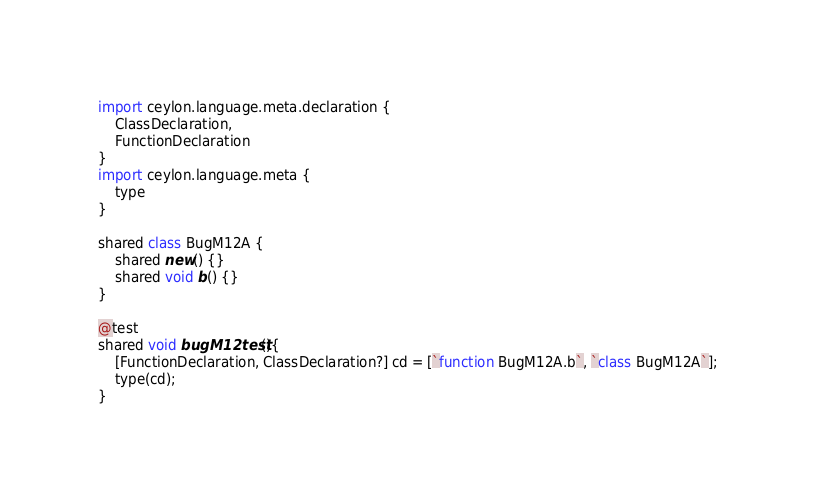Convert code to text. <code><loc_0><loc_0><loc_500><loc_500><_Ceylon_>import ceylon.language.meta.declaration {
    ClassDeclaration,
    FunctionDeclaration
}
import ceylon.language.meta {
    type
}

shared class BugM12A {
    shared new() {}    
    shared void b() {}
}

@test
shared void bugM12test(){
    [FunctionDeclaration, ClassDeclaration?] cd = [`function BugM12A.b`, `class BugM12A`];
    type(cd);
}</code> 